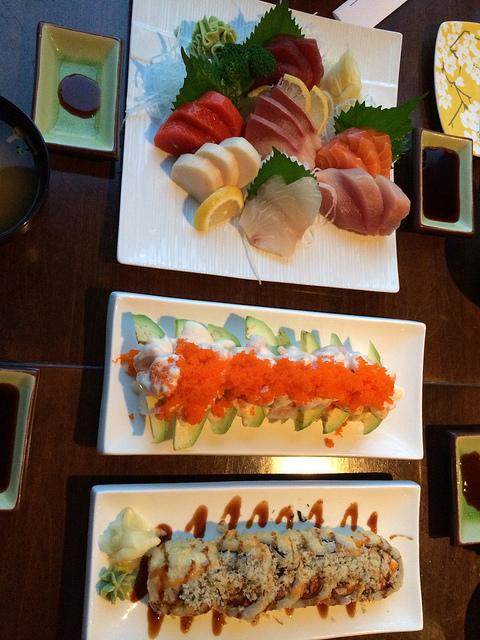In what type of establishment might these items be sold?
Give a very brief answer. Restaurant. What kind of fruit is used as a garnish on the top plate?
Concise answer only. Lemon. Is this a display?
Write a very short answer. Yes. Is this food good to eat?
Keep it brief. Yes. 